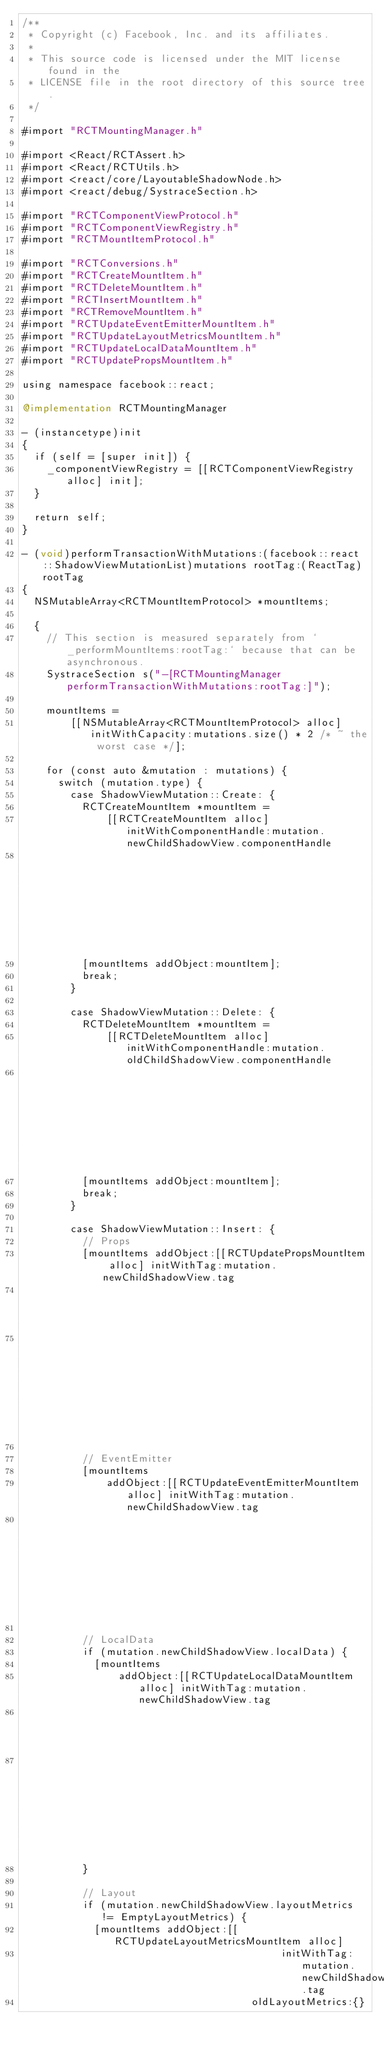<code> <loc_0><loc_0><loc_500><loc_500><_ObjectiveC_>/**
 * Copyright (c) Facebook, Inc. and its affiliates.
 *
 * This source code is licensed under the MIT license found in the
 * LICENSE file in the root directory of this source tree.
 */

#import "RCTMountingManager.h"

#import <React/RCTAssert.h>
#import <React/RCTUtils.h>
#import <react/core/LayoutableShadowNode.h>
#import <react/debug/SystraceSection.h>

#import "RCTComponentViewProtocol.h"
#import "RCTComponentViewRegistry.h"
#import "RCTMountItemProtocol.h"

#import "RCTConversions.h"
#import "RCTCreateMountItem.h"
#import "RCTDeleteMountItem.h"
#import "RCTInsertMountItem.h"
#import "RCTRemoveMountItem.h"
#import "RCTUpdateEventEmitterMountItem.h"
#import "RCTUpdateLayoutMetricsMountItem.h"
#import "RCTUpdateLocalDataMountItem.h"
#import "RCTUpdatePropsMountItem.h"

using namespace facebook::react;

@implementation RCTMountingManager

- (instancetype)init
{
  if (self = [super init]) {
    _componentViewRegistry = [[RCTComponentViewRegistry alloc] init];
  }

  return self;
}

- (void)performTransactionWithMutations:(facebook::react::ShadowViewMutationList)mutations rootTag:(ReactTag)rootTag
{
  NSMutableArray<RCTMountItemProtocol> *mountItems;

  {
    // This section is measured separately from `_performMountItems:rootTag:` because that can be asynchronous.
    SystraceSection s("-[RCTMountingManager performTransactionWithMutations:rootTag:]");

    mountItems =
        [[NSMutableArray<RCTMountItemProtocol> alloc] initWithCapacity:mutations.size() * 2 /* ~ the worst case */];

    for (const auto &mutation : mutations) {
      switch (mutation.type) {
        case ShadowViewMutation::Create: {
          RCTCreateMountItem *mountItem =
              [[RCTCreateMountItem alloc] initWithComponentHandle:mutation.newChildShadowView.componentHandle
                                                              tag:mutation.newChildShadowView.tag];
          [mountItems addObject:mountItem];
          break;
        }

        case ShadowViewMutation::Delete: {
          RCTDeleteMountItem *mountItem =
              [[RCTDeleteMountItem alloc] initWithComponentHandle:mutation.oldChildShadowView.componentHandle
                                                              tag:mutation.oldChildShadowView.tag];
          [mountItems addObject:mountItem];
          break;
        }

        case ShadowViewMutation::Insert: {
          // Props
          [mountItems addObject:[[RCTUpdatePropsMountItem alloc] initWithTag:mutation.newChildShadowView.tag
                                                                    oldProps:nullptr
                                                                    newProps:mutation.newChildShadowView.props]];

          // EventEmitter
          [mountItems
              addObject:[[RCTUpdateEventEmitterMountItem alloc] initWithTag:mutation.newChildShadowView.tag
                                                               eventEmitter:mutation.newChildShadowView.eventEmitter]];

          // LocalData
          if (mutation.newChildShadowView.localData) {
            [mountItems
                addObject:[[RCTUpdateLocalDataMountItem alloc] initWithTag:mutation.newChildShadowView.tag
                                                              oldLocalData:nullptr
                                                              newLocalData:mutation.newChildShadowView.localData]];
          }

          // Layout
          if (mutation.newChildShadowView.layoutMetrics != EmptyLayoutMetrics) {
            [mountItems addObject:[[RCTUpdateLayoutMetricsMountItem alloc]
                                           initWithTag:mutation.newChildShadowView.tag
                                      oldLayoutMetrics:{}</code> 